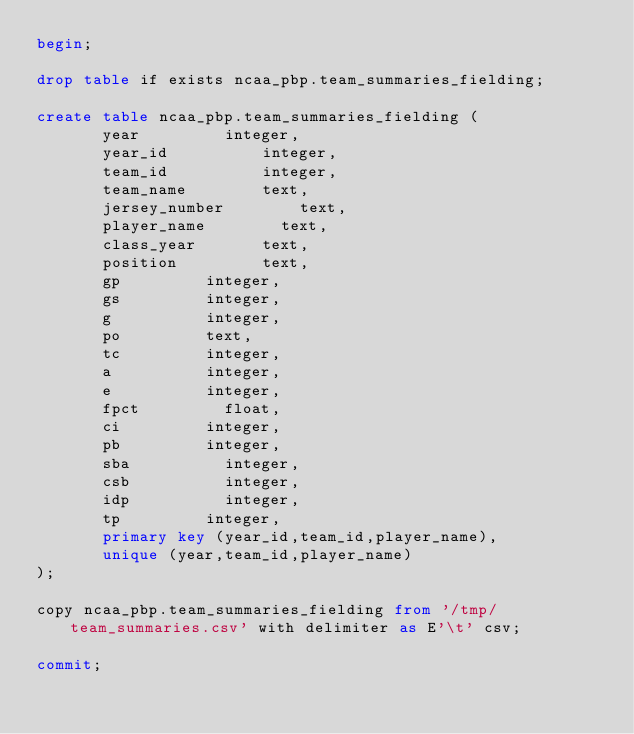Convert code to text. <code><loc_0><loc_0><loc_500><loc_500><_SQL_>begin;

drop table if exists ncaa_pbp.team_summaries_fielding;

create table ncaa_pbp.team_summaries_fielding (
       year					integer,
       year_id					integer,
       team_id					integer,
       team_name				text,
       jersey_number				text,
       player_name				text,
       class_year				text,
       position					text,
       gp					integer,
       gs					integer,
       g					integer,
       po					text,
       tc					integer,
       a					integer,
       e					integer,
       fpct					float,
       ci					integer,
       pb					integer,
       sba					integer,
       csb					integer,
       idp					integer,
       tp					integer,
       primary key (year_id,team_id,player_name),
       unique (year,team_id,player_name)
);

copy ncaa_pbp.team_summaries_fielding from '/tmp/team_summaries.csv' with delimiter as E'\t' csv;

commit;
</code> 